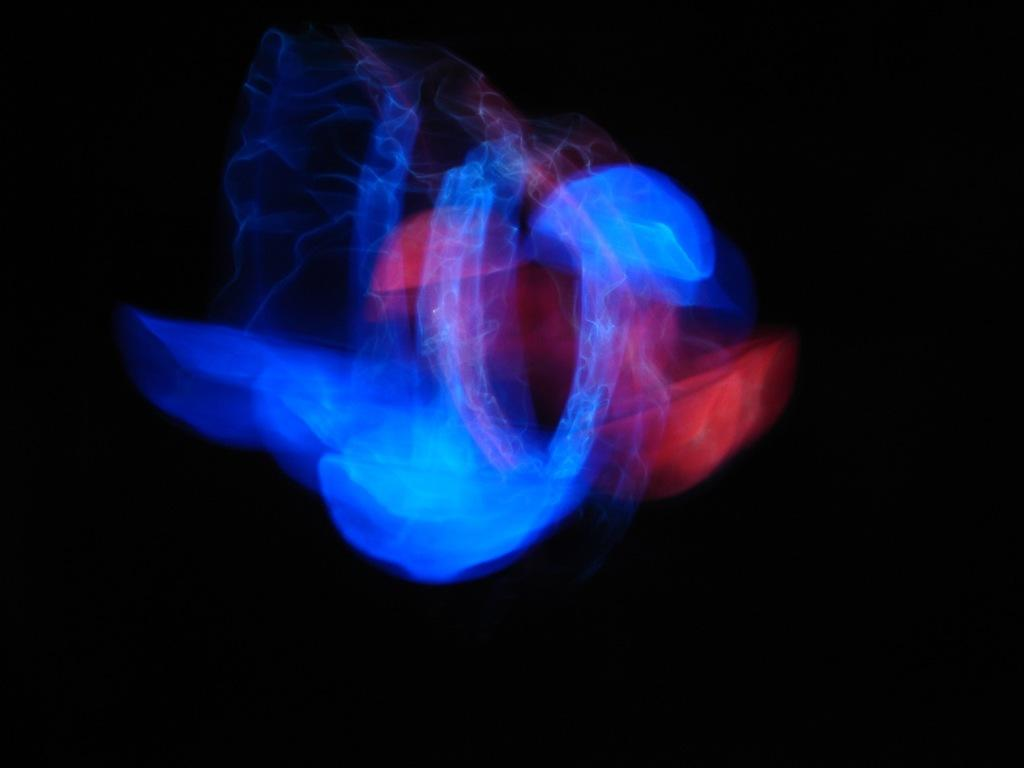What is located in the middle of the image? There are lights in the middle of the image. What can be observed about the background of the image? The background of the image is dark. Based on the darkness of the background, can we infer the time of day when the image was taken? The image may have been taken during the night, as the background is dark. What type of pet can be seen crawling on the ground in the image? There is no pet visible in the image; it only features lights and a dark background. 